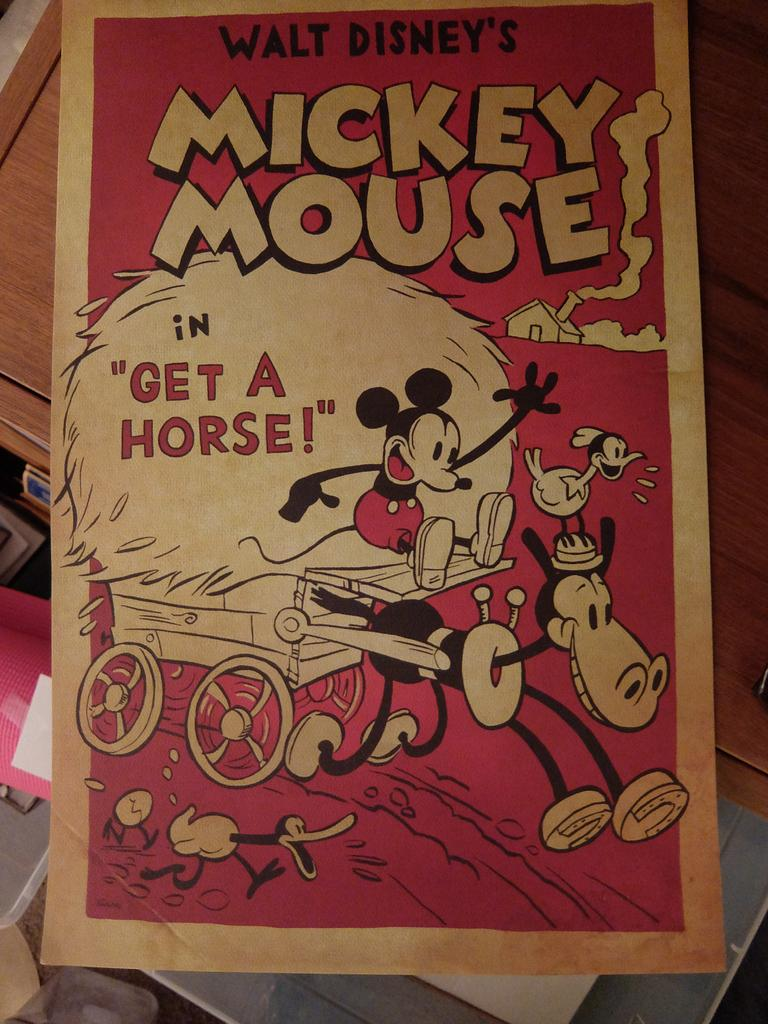Provide a one-sentence caption for the provided image. A pamphlet for Mickey Mouse's "Get a Horse" short. 